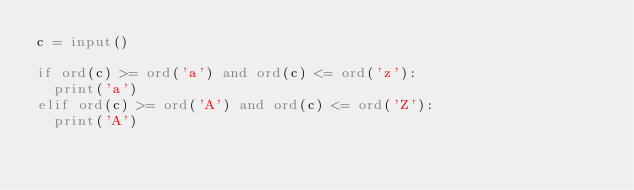Convert code to text. <code><loc_0><loc_0><loc_500><loc_500><_Python_>c = input()

if ord(c) >= ord('a') and ord(c) <= ord('z'):
  print('a')
elif ord(c) >= ord('A') and ord(c) <= ord('Z'):
  print('A')</code> 